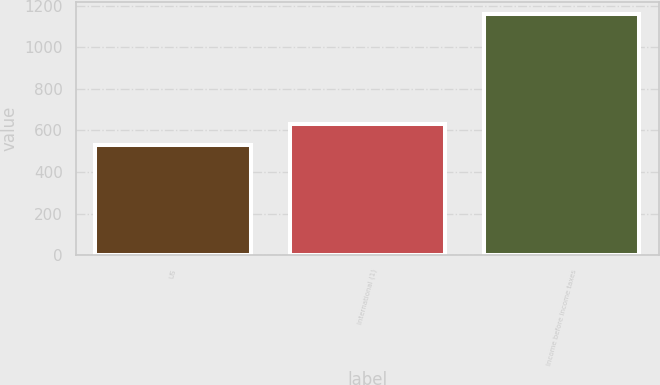Convert chart to OTSL. <chart><loc_0><loc_0><loc_500><loc_500><bar_chart><fcel>US<fcel>International (1)<fcel>Income before income taxes<nl><fcel>529<fcel>632<fcel>1161<nl></chart> 